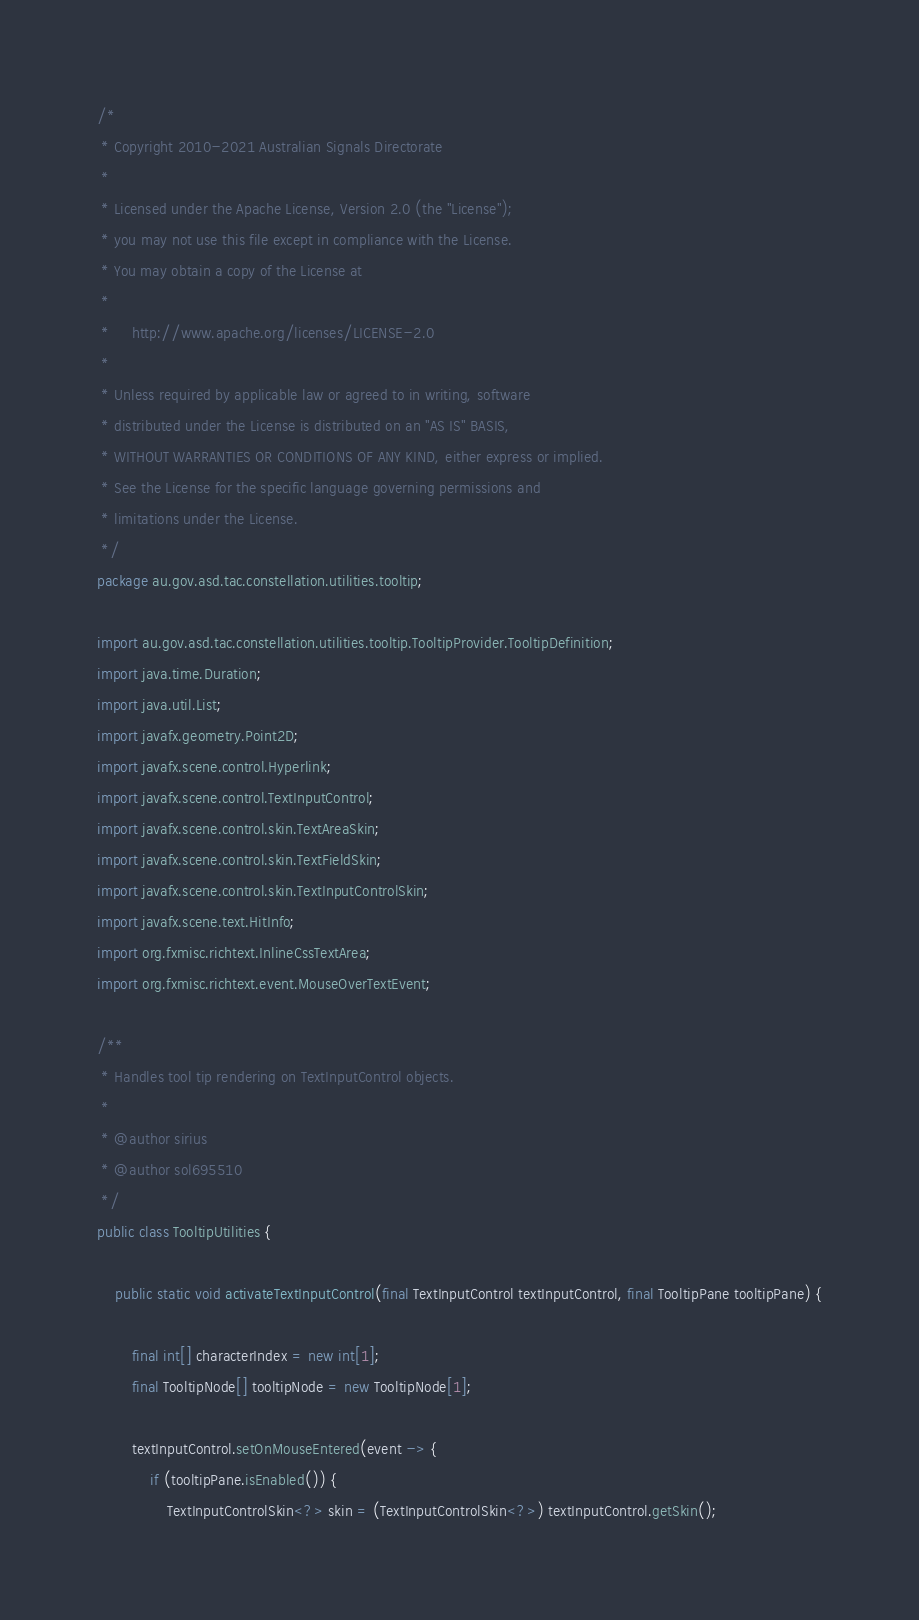Convert code to text. <code><loc_0><loc_0><loc_500><loc_500><_Java_>/*
 * Copyright 2010-2021 Australian Signals Directorate
 *
 * Licensed under the Apache License, Version 2.0 (the "License");
 * you may not use this file except in compliance with the License.
 * You may obtain a copy of the License at
 *
 *     http://www.apache.org/licenses/LICENSE-2.0
 *
 * Unless required by applicable law or agreed to in writing, software
 * distributed under the License is distributed on an "AS IS" BASIS,
 * WITHOUT WARRANTIES OR CONDITIONS OF ANY KIND, either express or implied.
 * See the License for the specific language governing permissions and
 * limitations under the License.
 */
package au.gov.asd.tac.constellation.utilities.tooltip;

import au.gov.asd.tac.constellation.utilities.tooltip.TooltipProvider.TooltipDefinition;
import java.time.Duration;
import java.util.List;
import javafx.geometry.Point2D;
import javafx.scene.control.Hyperlink;
import javafx.scene.control.TextInputControl;
import javafx.scene.control.skin.TextAreaSkin;
import javafx.scene.control.skin.TextFieldSkin;
import javafx.scene.control.skin.TextInputControlSkin;
import javafx.scene.text.HitInfo;
import org.fxmisc.richtext.InlineCssTextArea;
import org.fxmisc.richtext.event.MouseOverTextEvent;

/**
 * Handles tool tip rendering on TextInputControl objects.
 *
 * @author sirius
 * @author sol695510
 */
public class TooltipUtilities {

    public static void activateTextInputControl(final TextInputControl textInputControl, final TooltipPane tooltipPane) {

        final int[] characterIndex = new int[1];
        final TooltipNode[] tooltipNode = new TooltipNode[1];

        textInputControl.setOnMouseEntered(event -> {
            if (tooltipPane.isEnabled()) {
                TextInputControlSkin<?> skin = (TextInputControlSkin<?>) textInputControl.getSkin();</code> 